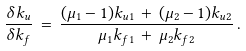<formula> <loc_0><loc_0><loc_500><loc_500>\frac { \delta k _ { u } } { \delta k _ { f } } \, = \, \frac { ( \mu _ { 1 } - 1 ) k _ { u 1 } \, + \, ( \mu _ { 2 } - 1 ) k _ { u 2 } } { \mu _ { 1 } k _ { f 1 } \, + \, \mu _ { 2 } k _ { f 2 } } \, .</formula> 